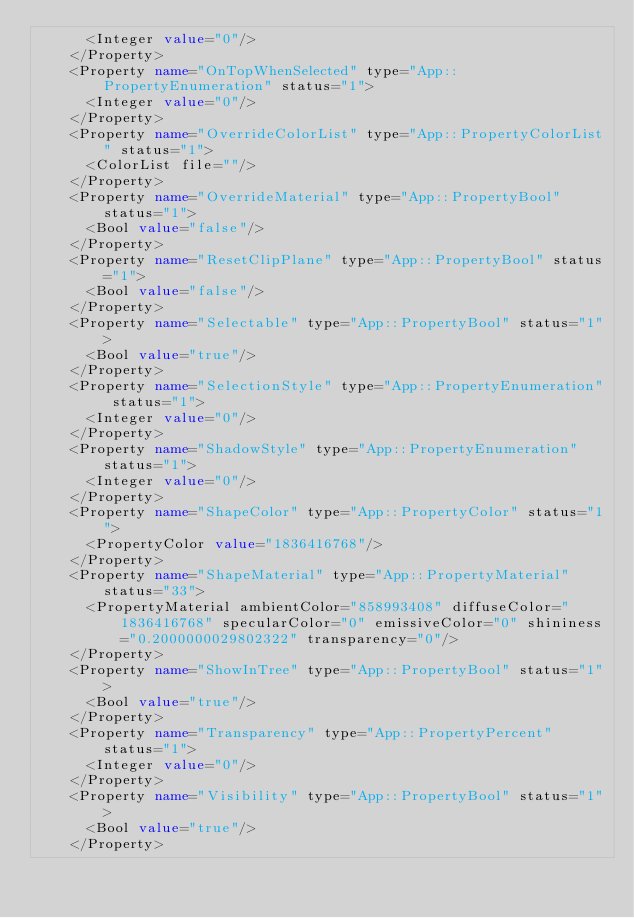<code> <loc_0><loc_0><loc_500><loc_500><_XML_>      <Integer value="0"/>
    </Property>
    <Property name="OnTopWhenSelected" type="App::PropertyEnumeration" status="1">
      <Integer value="0"/>
    </Property>
    <Property name="OverrideColorList" type="App::PropertyColorList" status="1">
      <ColorList file=""/>
    </Property>
    <Property name="OverrideMaterial" type="App::PropertyBool" status="1">
      <Bool value="false"/>
    </Property>
    <Property name="ResetClipPlane" type="App::PropertyBool" status="1">
      <Bool value="false"/>
    </Property>
    <Property name="Selectable" type="App::PropertyBool" status="1">
      <Bool value="true"/>
    </Property>
    <Property name="SelectionStyle" type="App::PropertyEnumeration" status="1">
      <Integer value="0"/>
    </Property>
    <Property name="ShadowStyle" type="App::PropertyEnumeration" status="1">
      <Integer value="0"/>
    </Property>
    <Property name="ShapeColor" type="App::PropertyColor" status="1">
      <PropertyColor value="1836416768"/>
    </Property>
    <Property name="ShapeMaterial" type="App::PropertyMaterial" status="33">
      <PropertyMaterial ambientColor="858993408" diffuseColor="1836416768" specularColor="0" emissiveColor="0" shininess="0.2000000029802322" transparency="0"/>
    </Property>
    <Property name="ShowInTree" type="App::PropertyBool" status="1">
      <Bool value="true"/>
    </Property>
    <Property name="Transparency" type="App::PropertyPercent" status="1">
      <Integer value="0"/>
    </Property>
    <Property name="Visibility" type="App::PropertyBool" status="1">
      <Bool value="true"/>
    </Property></code> 